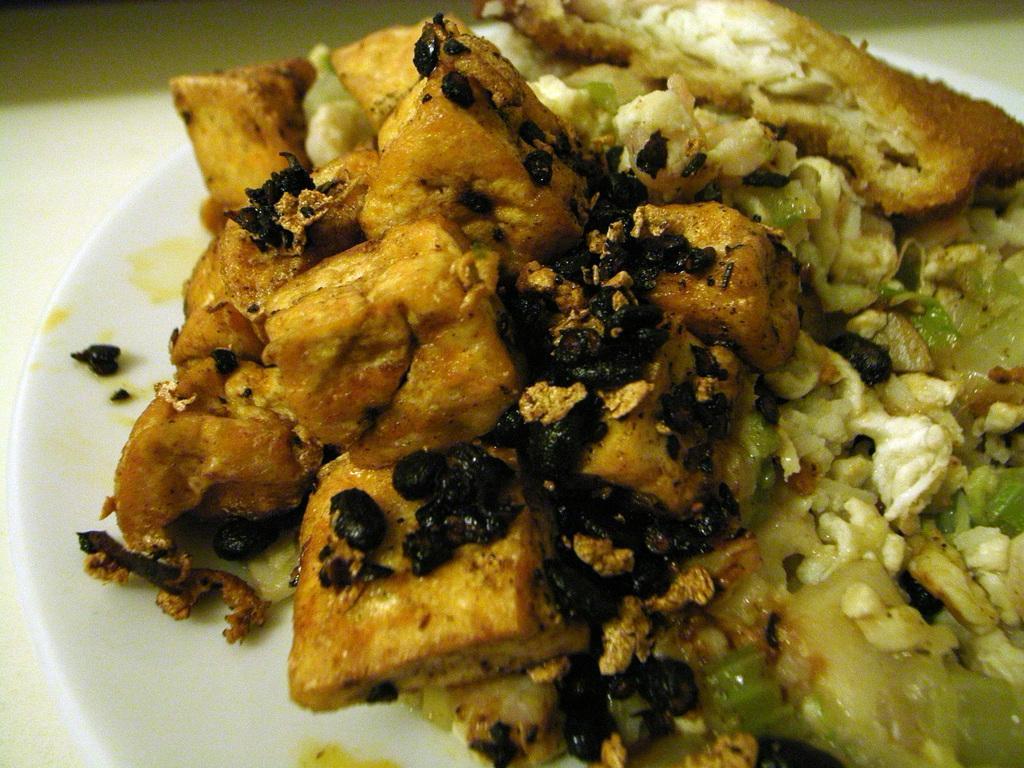Describe this image in one or two sentences. In this image I can see food items in a plate kept on the table. This image is taken may be in a room. 